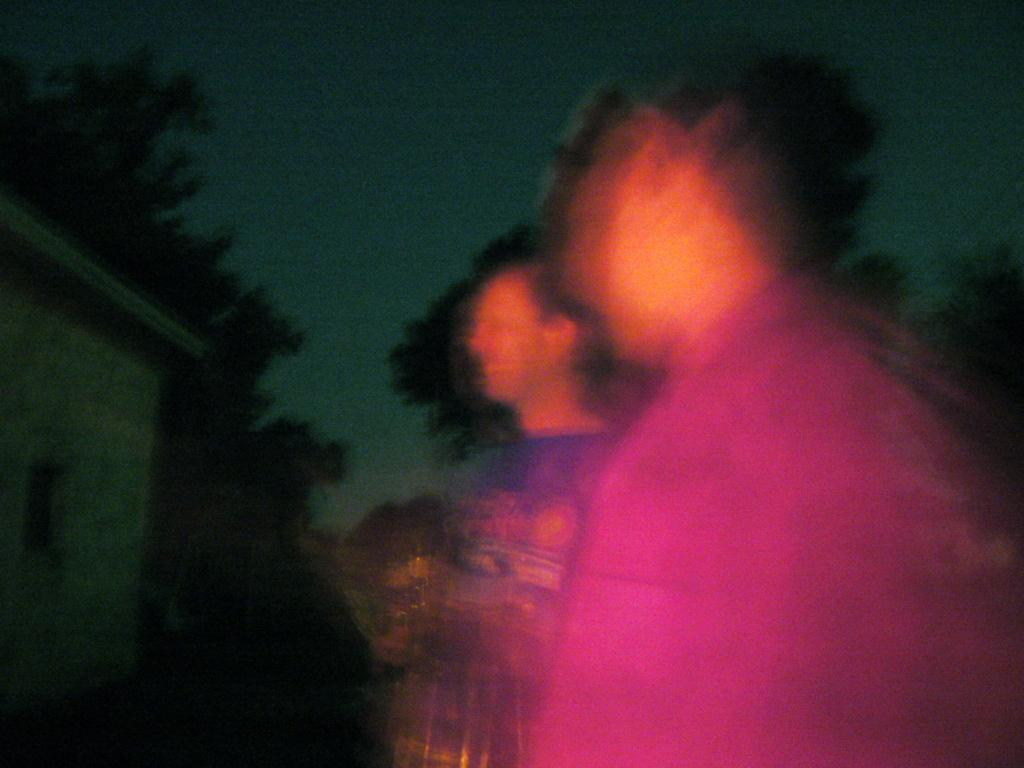How many people are in the image? There are two persons in the image. What is located behind the persons in the image? There is a wall in the image. What type of vegetation can be seen in the image? There are trees in the image. What is visible above the wall and trees in the image? The sky is visible in the image. What type of milk is being poured from the hand in the image? There is no hand or milk present in the image. 